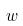<formula> <loc_0><loc_0><loc_500><loc_500>w</formula> 